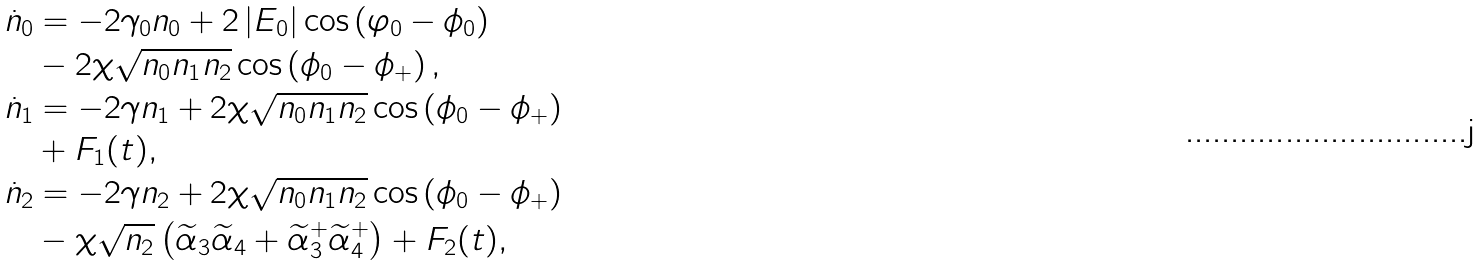Convert formula to latex. <formula><loc_0><loc_0><loc_500><loc_500>\dot { n } _ { 0 } & = - 2 \gamma _ { 0 } n _ { 0 } + 2 \left | E _ { 0 } \right | \cos \left ( \varphi _ { 0 } - \phi _ { 0 } \right ) \\ & - 2 \chi \sqrt { n _ { 0 } n _ { 1 } n _ { 2 } } \cos \left ( \phi _ { 0 } - \phi _ { + } \right ) , \\ \dot { n } _ { 1 } & = - 2 \gamma n _ { 1 } + 2 \chi \sqrt { n _ { 0 } n _ { 1 } n _ { 2 } } \cos \left ( \phi _ { 0 } - \phi _ { + } \right ) \\ & + F _ { 1 } ( t ) , \\ \dot { n } _ { 2 } & = - 2 \gamma n _ { 2 } + 2 \chi \sqrt { n _ { 0 } n _ { 1 } n _ { 2 } } \cos \left ( \phi _ { 0 } - \phi _ { + } \right ) \\ & - \chi \sqrt { n _ { 2 } } \left ( \widetilde { \alpha } _ { 3 } \widetilde { \alpha } _ { 4 } + \widetilde { \alpha } _ { 3 } ^ { + } \widetilde { \alpha } _ { 4 } ^ { + } \right ) + F _ { 2 } ( t ) ,</formula> 